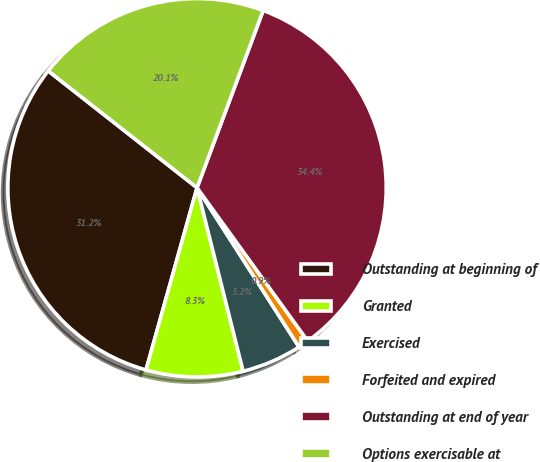Convert chart. <chart><loc_0><loc_0><loc_500><loc_500><pie_chart><fcel>Outstanding at beginning of<fcel>Granted<fcel>Exercised<fcel>Forfeited and expired<fcel>Outstanding at end of year<fcel>Options exercisable at<nl><fcel>31.25%<fcel>8.26%<fcel>5.15%<fcel>0.89%<fcel>34.36%<fcel>20.09%<nl></chart> 